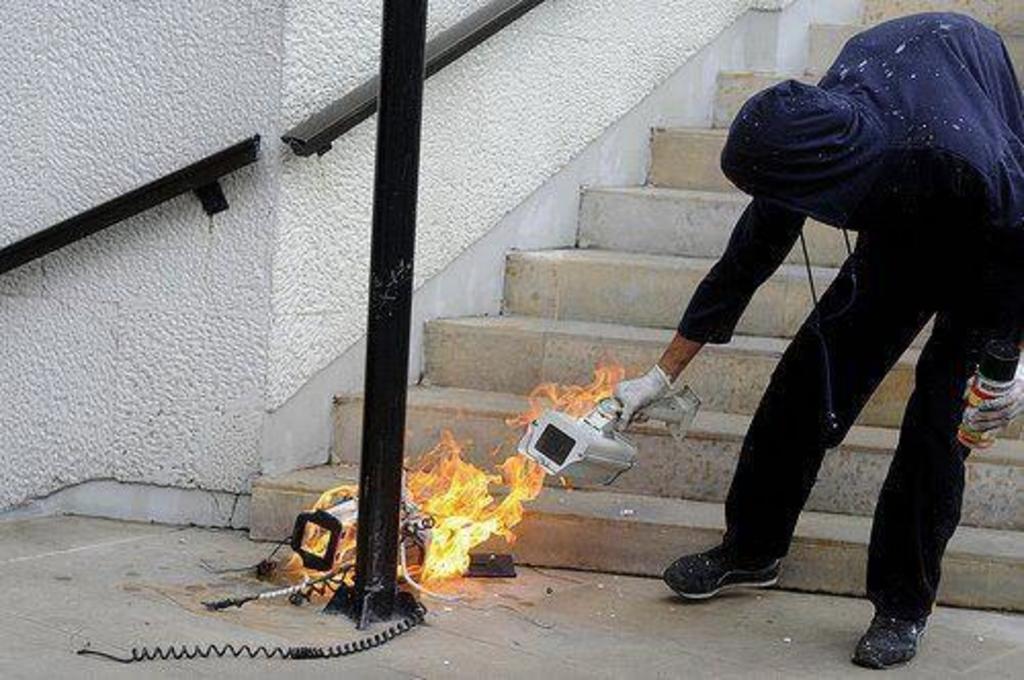How would you summarize this image in a sentence or two? In this picture we can see a person is holding a CCTV, there is a pole and fire in the middle, in the background we can see stairs. 